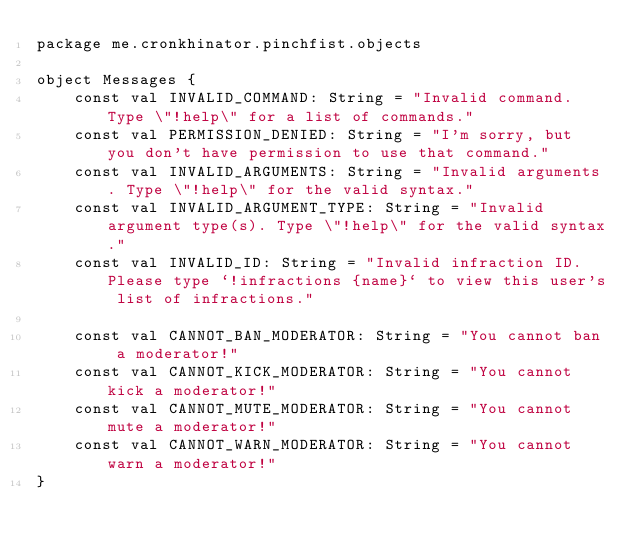<code> <loc_0><loc_0><loc_500><loc_500><_Kotlin_>package me.cronkhinator.pinchfist.objects

object Messages {
    const val INVALID_COMMAND: String = "Invalid command. Type \"!help\" for a list of commands."
    const val PERMISSION_DENIED: String = "I'm sorry, but you don't have permission to use that command."
    const val INVALID_ARGUMENTS: String = "Invalid arguments. Type \"!help\" for the valid syntax."
    const val INVALID_ARGUMENT_TYPE: String = "Invalid argument type(s). Type \"!help\" for the valid syntax."
    const val INVALID_ID: String = "Invalid infraction ID. Please type `!infractions {name}` to view this user's list of infractions."

    const val CANNOT_BAN_MODERATOR: String = "You cannot ban a moderator!"
    const val CANNOT_KICK_MODERATOR: String = "You cannot kick a moderator!"
    const val CANNOT_MUTE_MODERATOR: String = "You cannot mute a moderator!"
    const val CANNOT_WARN_MODERATOR: String = "You cannot warn a moderator!"
}</code> 